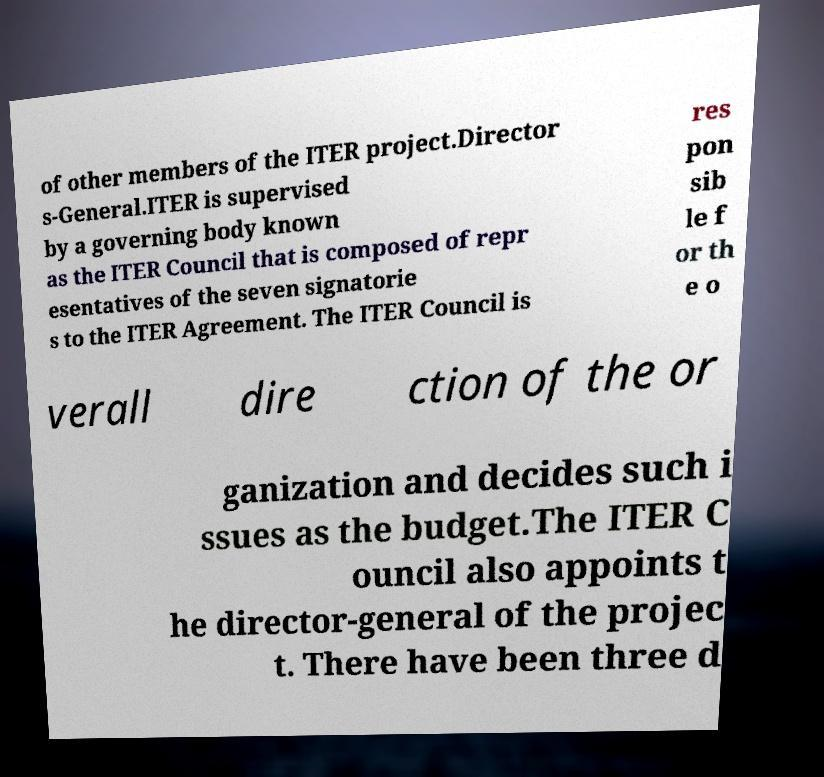Can you read and provide the text displayed in the image?This photo seems to have some interesting text. Can you extract and type it out for me? of other members of the ITER project.Director s-General.ITER is supervised by a governing body known as the ITER Council that is composed of repr esentatives of the seven signatorie s to the ITER Agreement. The ITER Council is res pon sib le f or th e o verall dire ction of the or ganization and decides such i ssues as the budget.The ITER C ouncil also appoints t he director-general of the projec t. There have been three d 